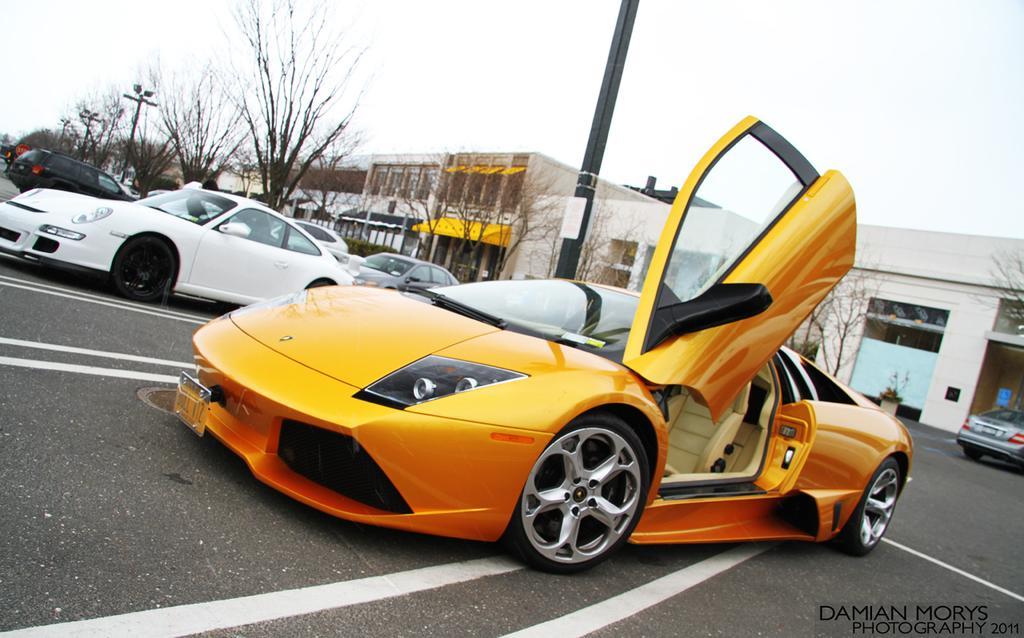Could you give a brief overview of what you see in this image? In the foreground of this image, there is an orange car with one door open is on the road. In the background, there are cars, poles, trees, buildings and the sky. 